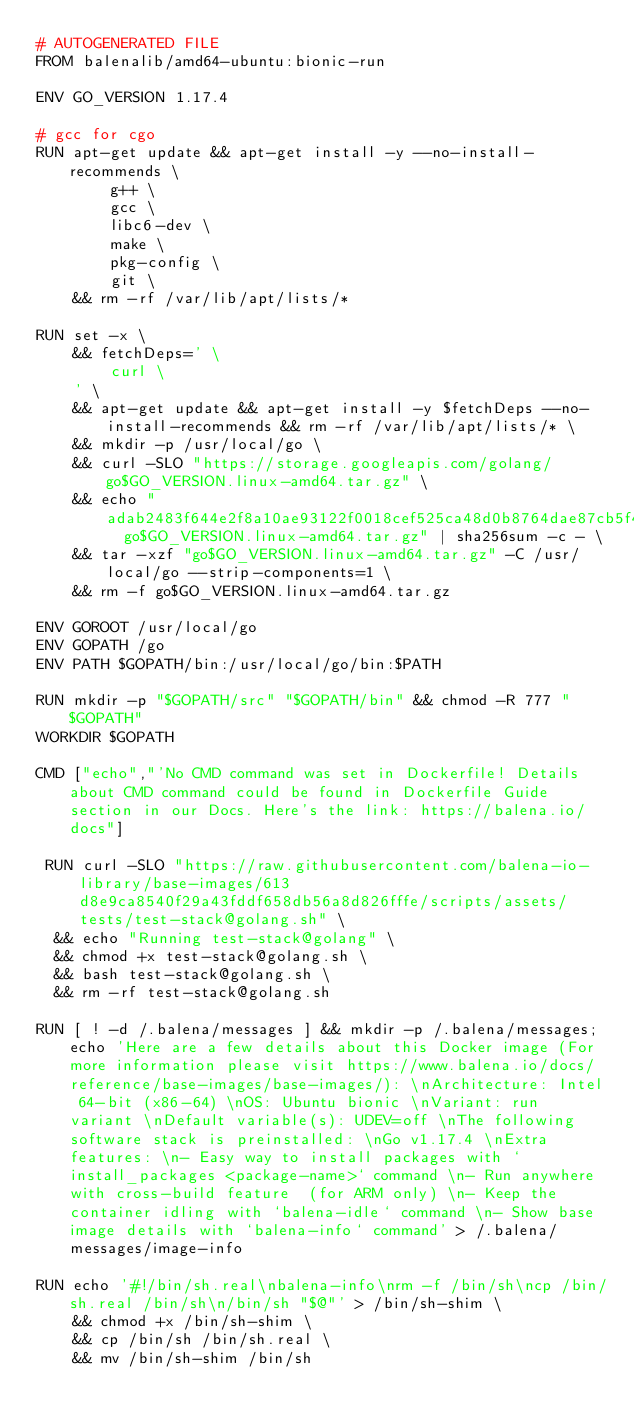Convert code to text. <code><loc_0><loc_0><loc_500><loc_500><_Dockerfile_># AUTOGENERATED FILE
FROM balenalib/amd64-ubuntu:bionic-run

ENV GO_VERSION 1.17.4

# gcc for cgo
RUN apt-get update && apt-get install -y --no-install-recommends \
		g++ \
		gcc \
		libc6-dev \
		make \
		pkg-config \
		git \
	&& rm -rf /var/lib/apt/lists/*

RUN set -x \
	&& fetchDeps=' \
		curl \
	' \
	&& apt-get update && apt-get install -y $fetchDeps --no-install-recommends && rm -rf /var/lib/apt/lists/* \
	&& mkdir -p /usr/local/go \
	&& curl -SLO "https://storage.googleapis.com/golang/go$GO_VERSION.linux-amd64.tar.gz" \
	&& echo "adab2483f644e2f8a10ae93122f0018cef525ca48d0b8764dae87cb5f4fd4206  go$GO_VERSION.linux-amd64.tar.gz" | sha256sum -c - \
	&& tar -xzf "go$GO_VERSION.linux-amd64.tar.gz" -C /usr/local/go --strip-components=1 \
	&& rm -f go$GO_VERSION.linux-amd64.tar.gz

ENV GOROOT /usr/local/go
ENV GOPATH /go
ENV PATH $GOPATH/bin:/usr/local/go/bin:$PATH

RUN mkdir -p "$GOPATH/src" "$GOPATH/bin" && chmod -R 777 "$GOPATH"
WORKDIR $GOPATH

CMD ["echo","'No CMD command was set in Dockerfile! Details about CMD command could be found in Dockerfile Guide section in our Docs. Here's the link: https://balena.io/docs"]

 RUN curl -SLO "https://raw.githubusercontent.com/balena-io-library/base-images/613d8e9ca8540f29a43fddf658db56a8d826fffe/scripts/assets/tests/test-stack@golang.sh" \
  && echo "Running test-stack@golang" \
  && chmod +x test-stack@golang.sh \
  && bash test-stack@golang.sh \
  && rm -rf test-stack@golang.sh 

RUN [ ! -d /.balena/messages ] && mkdir -p /.balena/messages; echo 'Here are a few details about this Docker image (For more information please visit https://www.balena.io/docs/reference/base-images/base-images/): \nArchitecture: Intel 64-bit (x86-64) \nOS: Ubuntu bionic \nVariant: run variant \nDefault variable(s): UDEV=off \nThe following software stack is preinstalled: \nGo v1.17.4 \nExtra features: \n- Easy way to install packages with `install_packages <package-name>` command \n- Run anywhere with cross-build feature  (for ARM only) \n- Keep the container idling with `balena-idle` command \n- Show base image details with `balena-info` command' > /.balena/messages/image-info

RUN echo '#!/bin/sh.real\nbalena-info\nrm -f /bin/sh\ncp /bin/sh.real /bin/sh\n/bin/sh "$@"' > /bin/sh-shim \
	&& chmod +x /bin/sh-shim \
	&& cp /bin/sh /bin/sh.real \
	&& mv /bin/sh-shim /bin/sh</code> 